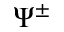<formula> <loc_0><loc_0><loc_500><loc_500>\Psi ^ { \pm }</formula> 